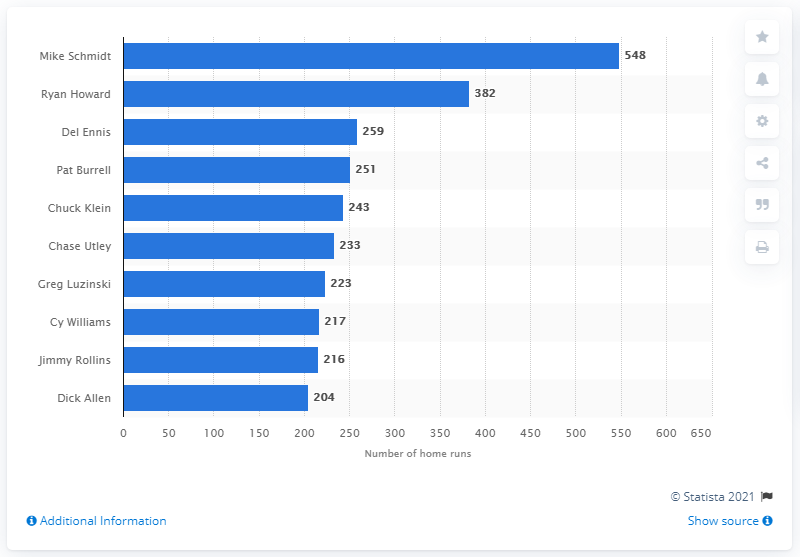List a handful of essential elements in this visual. Mike Schmidt, a professional baseball player, has hit a total of 548 home runs during his career. The record for the most home runs in franchise history belongs to Mike Schmidt, who hit an impressive number of home runs during his tenure with the team. 